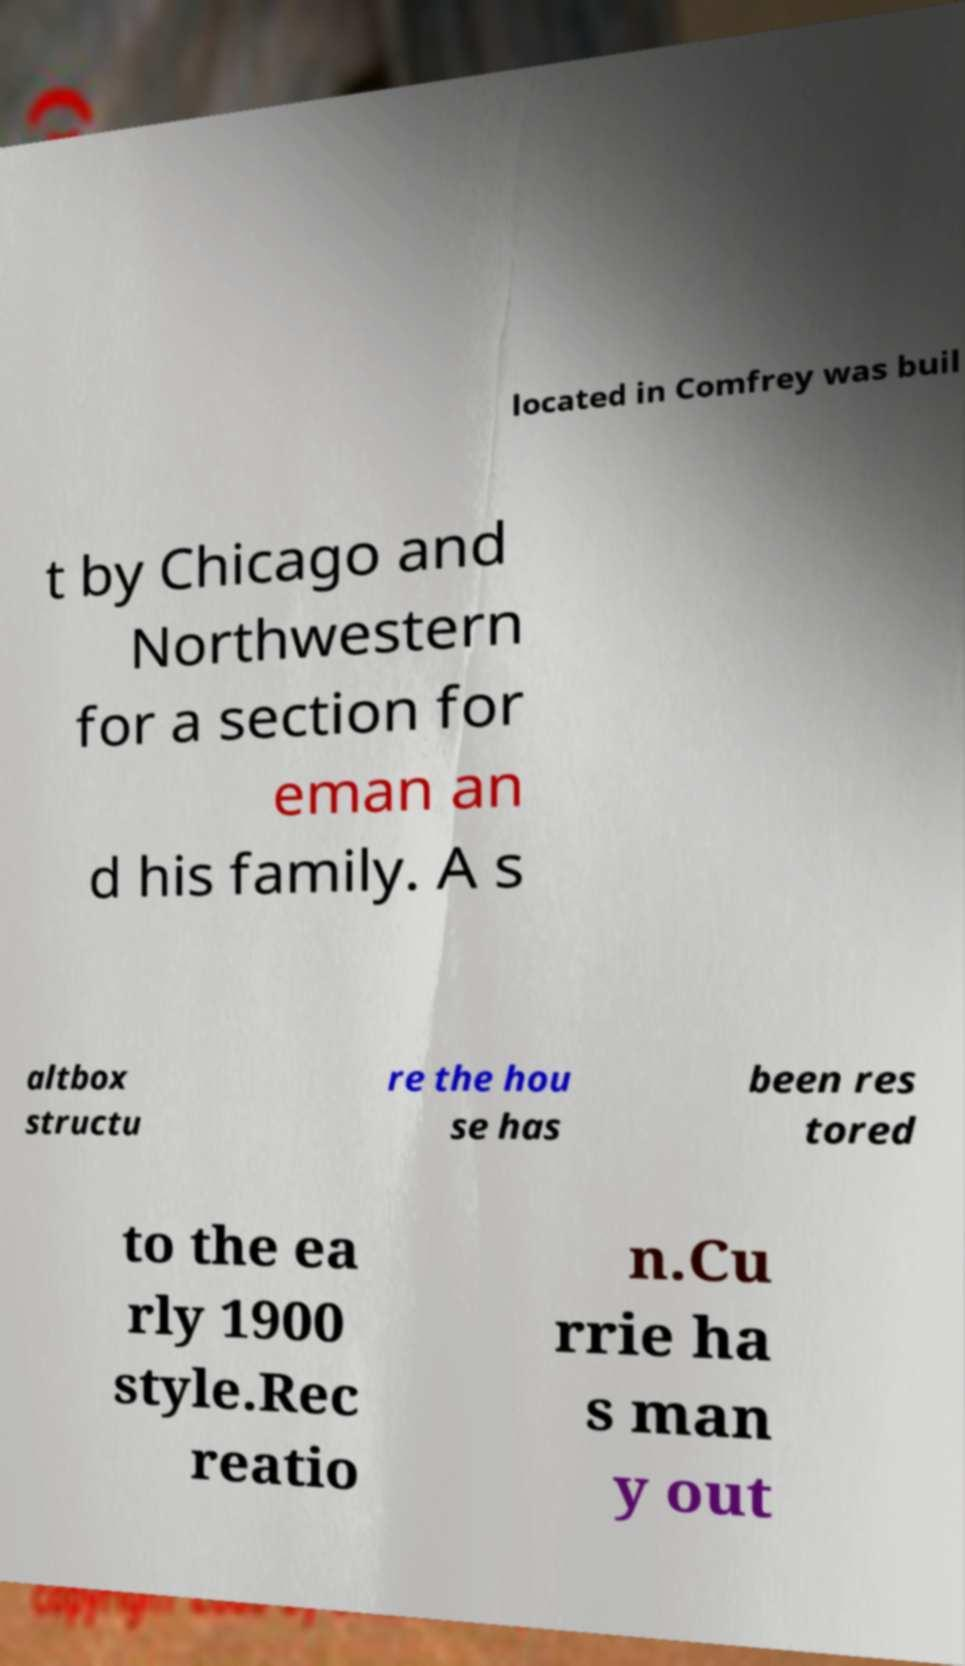For documentation purposes, I need the text within this image transcribed. Could you provide that? located in Comfrey was buil t by Chicago and Northwestern for a section for eman an d his family. A s altbox structu re the hou se has been res tored to the ea rly 1900 style.Rec reatio n.Cu rrie ha s man y out 